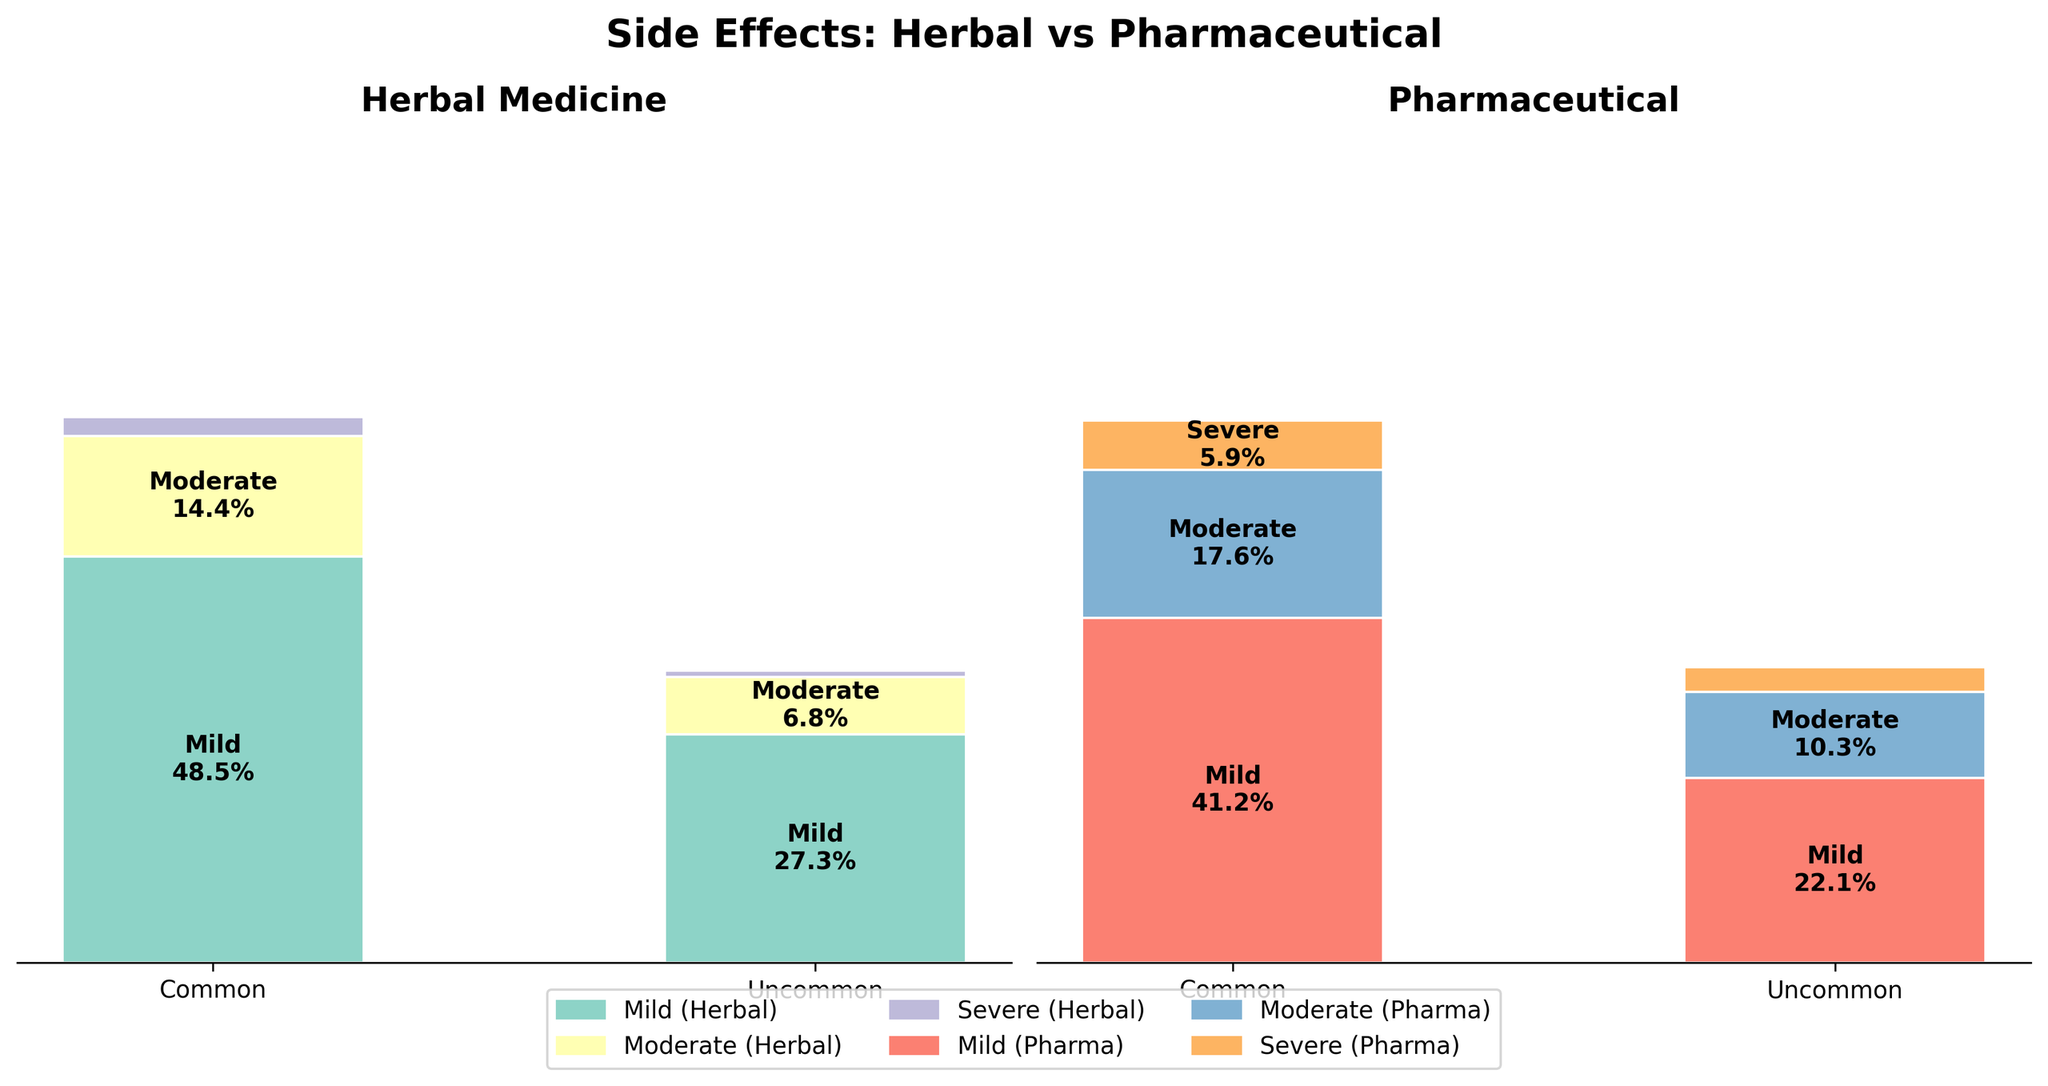How many common mild side effects are reported for herbal medicine? To find the number of common mild side effects for herbal medicine, refer to the segment in the Herbal Medicine chart that corresponds to 'Mild' and 'Common'. This segment has a label showing 320 cases.
Answer: 320 Which type of medicine has a higher proportion of severe common side effects? To determine which type of medicine has a higher proportion of severe common side effects, compare the 'Severe' and 'Common' segment on both charts. Herbal Medicine shows a smaller segment for this category compared to Pharmaceutical Medicine.
Answer: Pharmaceutical What is the total count of moderate side effects for pharmaceutical medicine? To determine the total count of moderate side effects for pharmaceutical medicine, sum the counts of moderate common and moderate uncommon side effects. From the chart, these are 120 (common) and 70 (uncommon). Thus, 120 + 70 = 190.
Answer: 190 For herbal medicine, which has a higher proportion: mild uncommon side effects or moderate common side effects? Compare the 'Mild' and 'Uncommon' segment to the 'Moderate' and 'Common' segment in the Herbal Medicine chart. The 'Mild' and 'Uncommon' segment shows a larger area than the 'Moderate' and 'Common' one.
Answer: Mild uncommon side effects What percentage of common side effects are mild for pharmaceutical medicine? The total count of common side effects for pharmaceutical medicine is obtained by summing mild, moderate, and severe common counts: 280 (mild) + 120 (moderate) + 40 (severe) = 440. The proportion of mild common is 280 out of 440, i.e., 280/440 = 0.636, which translates to 63.6%.
Answer: 63.6% What is the count difference between uncommon severe side effects for herbal and pharmaceutical medicines? To find the count difference, subtract the number of uncommon severe side effects for herbal medicine (5) from that of pharmaceutical medicine (20). Thus, 20 - 5 = 15.
Answer: 15 Between herbal and pharmaceutical medicines, which one has a higher proportion of moderate side effects overall? Sum the proportions of common and uncommon moderate side effects for each type of medicine and compare the total. For Herbal, moderate common (95) and uncommon (45) total to 140 out of 660 total side effects. For Pharmaceutical, moderate common (120) and uncommon (70) total to 190 out of 680 total side effects. Thus, Herbal: 140/660 and Pharma: 190/680. This translates approximately 21.2% for Herbal and 27.9% for Pharmaceutical.
Answer: Pharmaceutical 